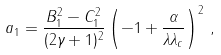Convert formula to latex. <formula><loc_0><loc_0><loc_500><loc_500>a _ { 1 } = \frac { B _ { 1 } ^ { 2 } - C _ { 1 } ^ { 2 } } { ( 2 \gamma + 1 ) ^ { 2 } } \left ( - 1 + \frac { \alpha } { \lambda \lambda _ { c } } \right ) ^ { 2 } \, { , }</formula> 